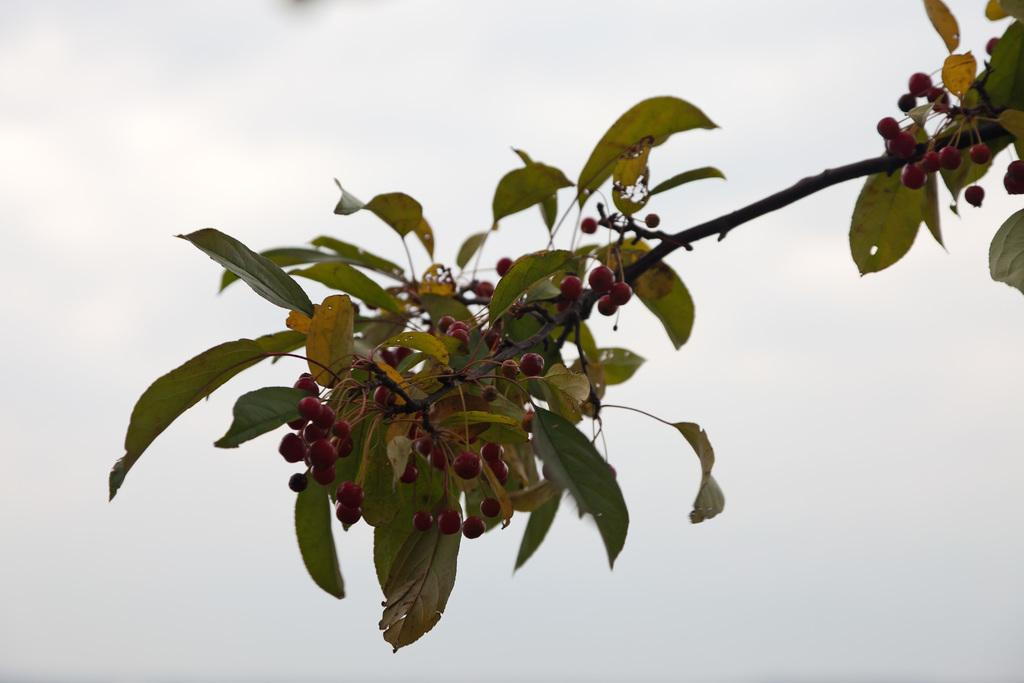What is present in the image? There is a tree in the image. What is special about the tree? The tree has fruits. What color are the fruits? The fruits are red in color. What can be seen in the background of the image? The sky is visible in the background of the image. How much profit does the lawyer make from the red fruits in the image? There is no lawyer or mention of profit in the image; it features a tree with red fruits and a visible sky. 